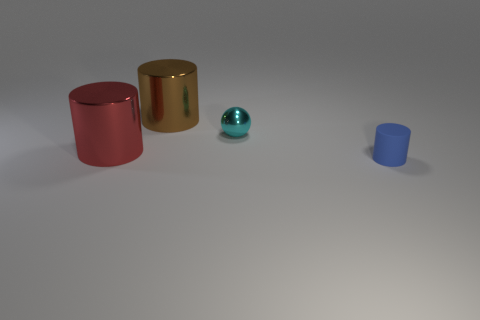Do the object that is to the right of the cyan shiny sphere and the cyan object have the same shape?
Make the answer very short. No. What number of objects are to the right of the tiny shiny object and to the left of the small blue cylinder?
Provide a short and direct response. 0. What material is the large red thing?
Keep it short and to the point. Metal. Is there any other thing of the same color as the ball?
Offer a very short reply. No. Does the tiny cyan thing have the same material as the tiny blue cylinder?
Offer a terse response. No. What number of shiny cylinders are behind the metallic cylinder left of the metal cylinder behind the cyan sphere?
Ensure brevity in your answer.  1. How many rubber objects are there?
Make the answer very short. 1. Are there fewer cyan objects that are in front of the matte cylinder than small cyan metallic objects to the right of the small metallic ball?
Your response must be concise. No. Are there fewer tiny shiny things in front of the tiny cyan ball than brown shiny cylinders?
Your response must be concise. Yes. There is a large cylinder behind the tiny object that is to the left of the small thing that is in front of the cyan sphere; what is it made of?
Your response must be concise. Metal. 